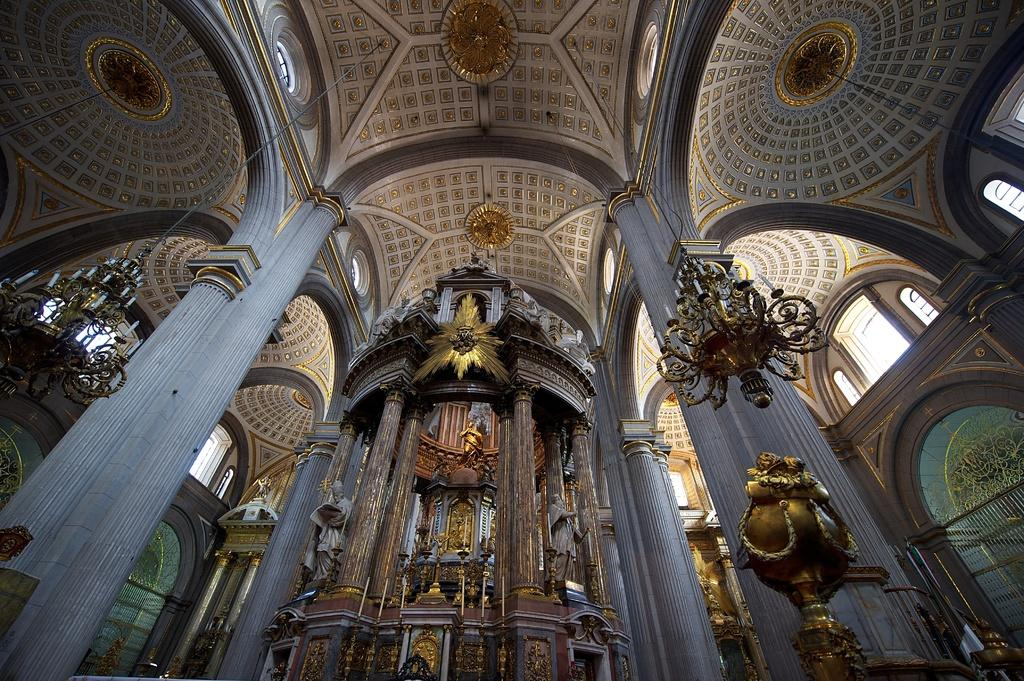What type of location is shown in the image? The image depicts an inside view of a building. What type of lighting is present in the image? There are chandelier lights in the image. What type of decorative objects can be seen in the image? There are sculptures in the image. Can you touch the spot where the chandelier lights are located in the image? You cannot touch the spot where the chandelier lights are located in the image, as it is a two-dimensional representation and not a physical object. 